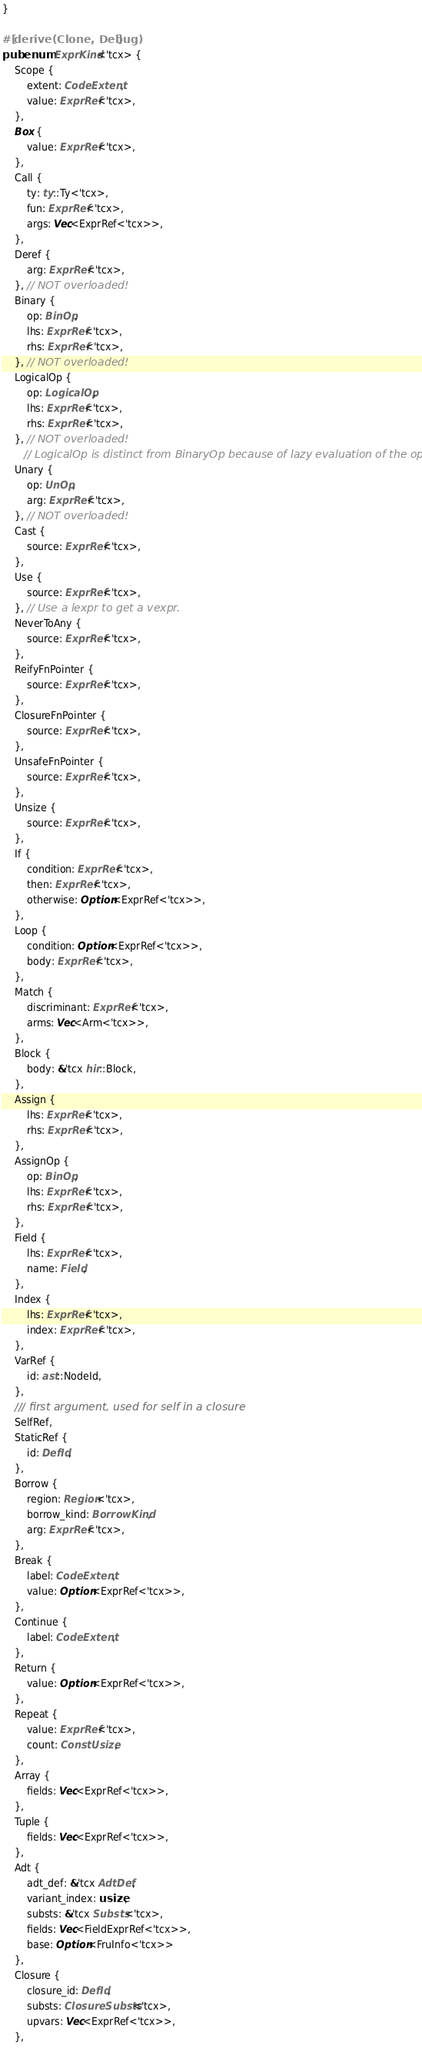Convert code to text. <code><loc_0><loc_0><loc_500><loc_500><_Rust_>}

#[derive(Clone, Debug)]
pub enum ExprKind<'tcx> {
    Scope {
        extent: CodeExtent,
        value: ExprRef<'tcx>,
    },
    Box {
        value: ExprRef<'tcx>,
    },
    Call {
        ty: ty::Ty<'tcx>,
        fun: ExprRef<'tcx>,
        args: Vec<ExprRef<'tcx>>,
    },
    Deref {
        arg: ExprRef<'tcx>,
    }, // NOT overloaded!
    Binary {
        op: BinOp,
        lhs: ExprRef<'tcx>,
        rhs: ExprRef<'tcx>,
    }, // NOT overloaded!
    LogicalOp {
        op: LogicalOp,
        lhs: ExprRef<'tcx>,
        rhs: ExprRef<'tcx>,
    }, // NOT overloaded!
       // LogicalOp is distinct from BinaryOp because of lazy evaluation of the operands.
    Unary {
        op: UnOp,
        arg: ExprRef<'tcx>,
    }, // NOT overloaded!
    Cast {
        source: ExprRef<'tcx>,
    },
    Use {
        source: ExprRef<'tcx>,
    }, // Use a lexpr to get a vexpr.
    NeverToAny {
        source: ExprRef<'tcx>,
    },
    ReifyFnPointer {
        source: ExprRef<'tcx>,
    },
    ClosureFnPointer {
        source: ExprRef<'tcx>,
    },
    UnsafeFnPointer {
        source: ExprRef<'tcx>,
    },
    Unsize {
        source: ExprRef<'tcx>,
    },
    If {
        condition: ExprRef<'tcx>,
        then: ExprRef<'tcx>,
        otherwise: Option<ExprRef<'tcx>>,
    },
    Loop {
        condition: Option<ExprRef<'tcx>>,
        body: ExprRef<'tcx>,
    },
    Match {
        discriminant: ExprRef<'tcx>,
        arms: Vec<Arm<'tcx>>,
    },
    Block {
        body: &'tcx hir::Block,
    },
    Assign {
        lhs: ExprRef<'tcx>,
        rhs: ExprRef<'tcx>,
    },
    AssignOp {
        op: BinOp,
        lhs: ExprRef<'tcx>,
        rhs: ExprRef<'tcx>,
    },
    Field {
        lhs: ExprRef<'tcx>,
        name: Field,
    },
    Index {
        lhs: ExprRef<'tcx>,
        index: ExprRef<'tcx>,
    },
    VarRef {
        id: ast::NodeId,
    },
    /// first argument, used for self in a closure
    SelfRef,
    StaticRef {
        id: DefId,
    },
    Borrow {
        region: Region<'tcx>,
        borrow_kind: BorrowKind,
        arg: ExprRef<'tcx>,
    },
    Break {
        label: CodeExtent,
        value: Option<ExprRef<'tcx>>,
    },
    Continue {
        label: CodeExtent,
    },
    Return {
        value: Option<ExprRef<'tcx>>,
    },
    Repeat {
        value: ExprRef<'tcx>,
        count: ConstUsize,
    },
    Array {
        fields: Vec<ExprRef<'tcx>>,
    },
    Tuple {
        fields: Vec<ExprRef<'tcx>>,
    },
    Adt {
        adt_def: &'tcx AdtDef,
        variant_index: usize,
        substs: &'tcx Substs<'tcx>,
        fields: Vec<FieldExprRef<'tcx>>,
        base: Option<FruInfo<'tcx>>
    },
    Closure {
        closure_id: DefId,
        substs: ClosureSubsts<'tcx>,
        upvars: Vec<ExprRef<'tcx>>,
    },</code> 